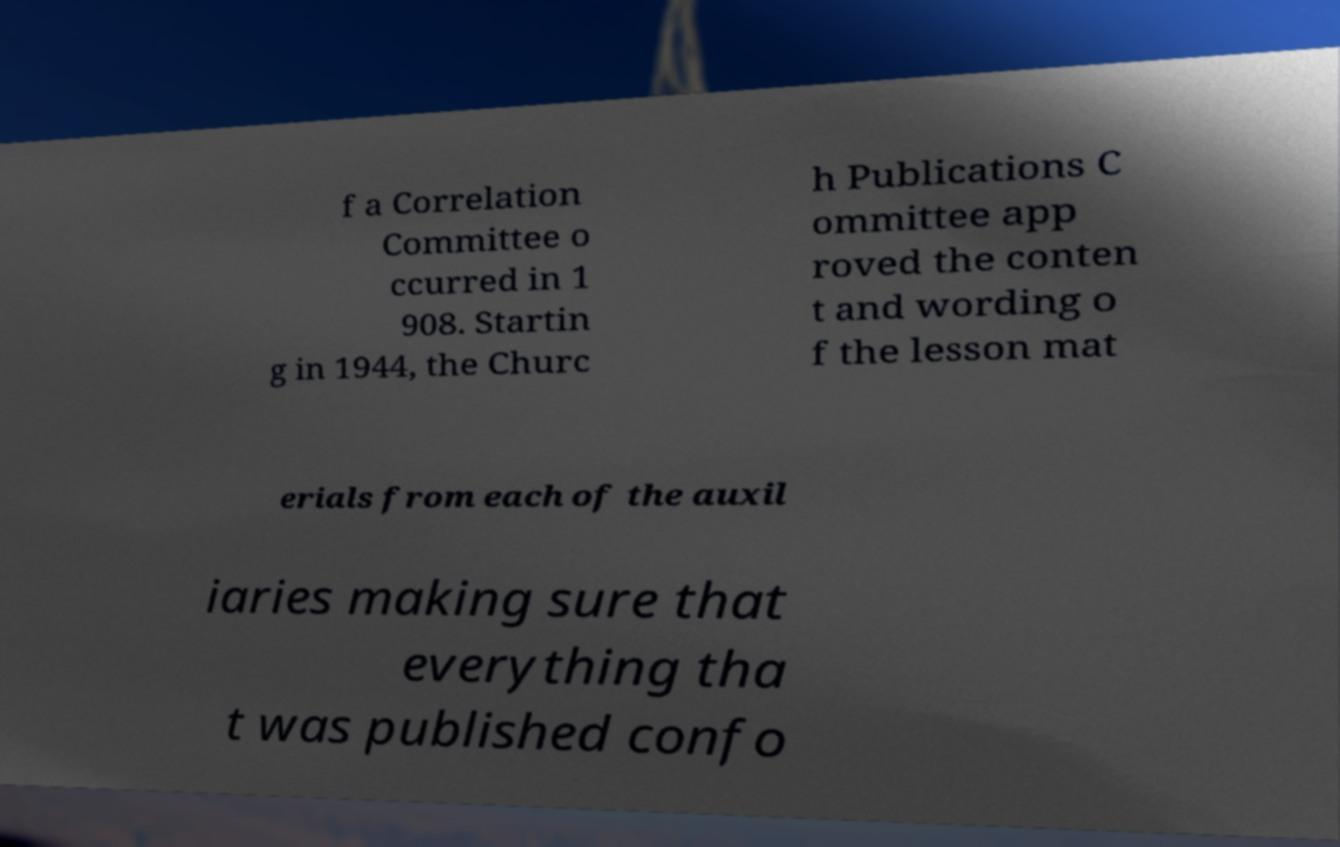Please identify and transcribe the text found in this image. f a Correlation Committee o ccurred in 1 908. Startin g in 1944, the Churc h Publications C ommittee app roved the conten t and wording o f the lesson mat erials from each of the auxil iaries making sure that everything tha t was published confo 